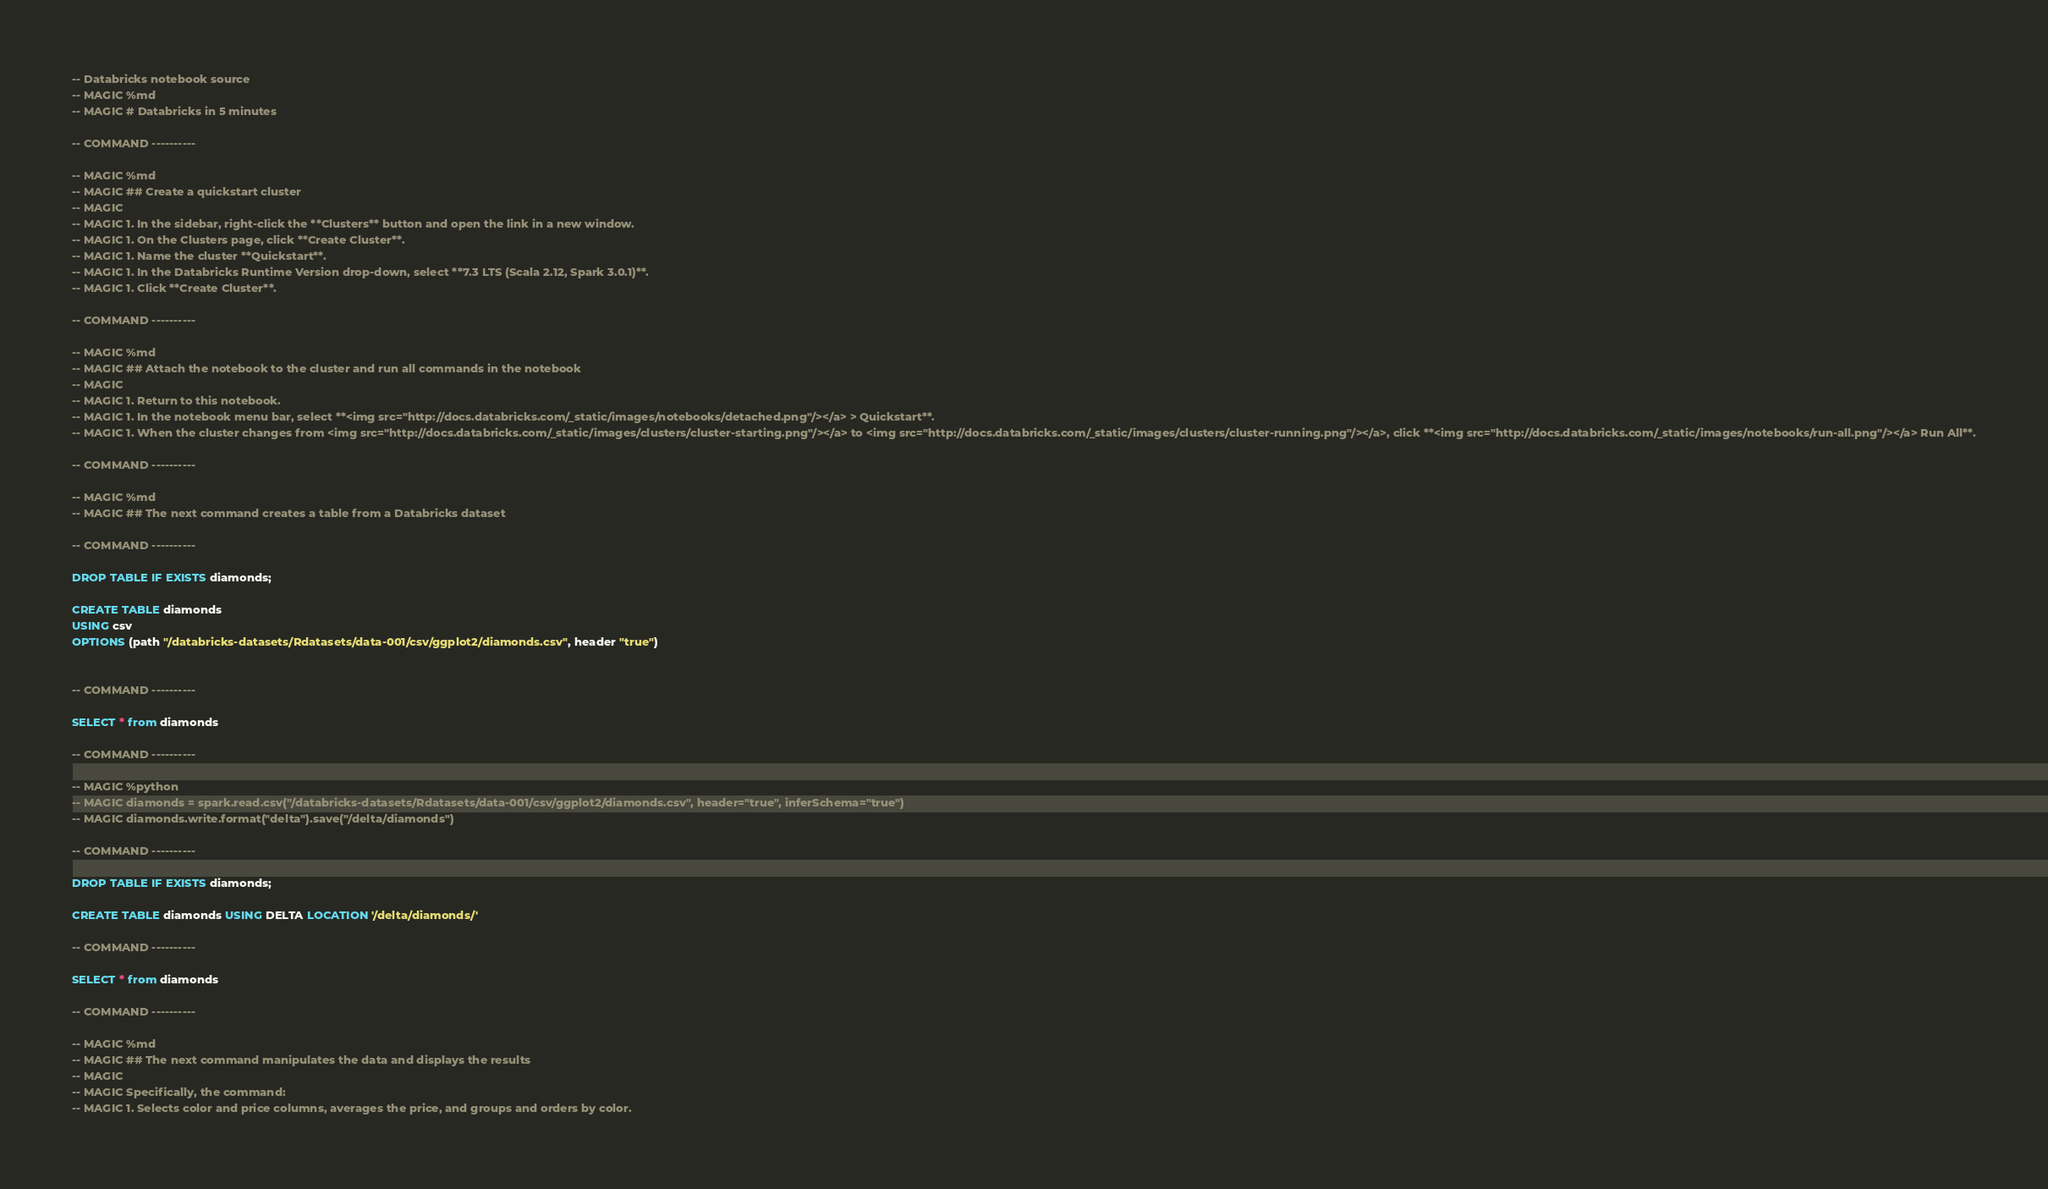Convert code to text. <code><loc_0><loc_0><loc_500><loc_500><_SQL_>-- Databricks notebook source
-- MAGIC %md
-- MAGIC # Databricks in 5 minutes

-- COMMAND ----------

-- MAGIC %md
-- MAGIC ## Create a quickstart cluster
-- MAGIC 
-- MAGIC 1. In the sidebar, right-click the **Clusters** button and open the link in a new window.
-- MAGIC 1. On the Clusters page, click **Create Cluster**.
-- MAGIC 1. Name the cluster **Quickstart**.
-- MAGIC 1. In the Databricks Runtime Version drop-down, select **7.3 LTS (Scala 2.12, Spark 3.0.1)**.
-- MAGIC 1. Click **Create Cluster**.

-- COMMAND ----------

-- MAGIC %md
-- MAGIC ## Attach the notebook to the cluster and run all commands in the notebook
-- MAGIC 
-- MAGIC 1. Return to this notebook. 
-- MAGIC 1. In the notebook menu bar, select **<img src="http://docs.databricks.com/_static/images/notebooks/detached.png"/></a> > Quickstart**.
-- MAGIC 1. When the cluster changes from <img src="http://docs.databricks.com/_static/images/clusters/cluster-starting.png"/></a> to <img src="http://docs.databricks.com/_static/images/clusters/cluster-running.png"/></a>, click **<img src="http://docs.databricks.com/_static/images/notebooks/run-all.png"/></a> Run All**.

-- COMMAND ----------

-- MAGIC %md 
-- MAGIC ## The next command creates a table from a Databricks dataset

-- COMMAND ----------

DROP TABLE IF EXISTS diamonds;

CREATE TABLE diamonds
USING csv
OPTIONS (path "/databricks-datasets/Rdatasets/data-001/csv/ggplot2/diamonds.csv", header "true")


-- COMMAND ----------

SELECT * from diamonds

-- COMMAND ----------

-- MAGIC %python
-- MAGIC diamonds = spark.read.csv("/databricks-datasets/Rdatasets/data-001/csv/ggplot2/diamonds.csv", header="true", inferSchema="true")
-- MAGIC diamonds.write.format("delta").save("/delta/diamonds")

-- COMMAND ----------

DROP TABLE IF EXISTS diamonds;

CREATE TABLE diamonds USING DELTA LOCATION '/delta/diamonds/'

-- COMMAND ----------

SELECT * from diamonds

-- COMMAND ----------

-- MAGIC %md
-- MAGIC ## The next command manipulates the data and displays the results 
-- MAGIC 
-- MAGIC Specifically, the command:
-- MAGIC 1. Selects color and price columns, averages the price, and groups and orders by color.</code> 